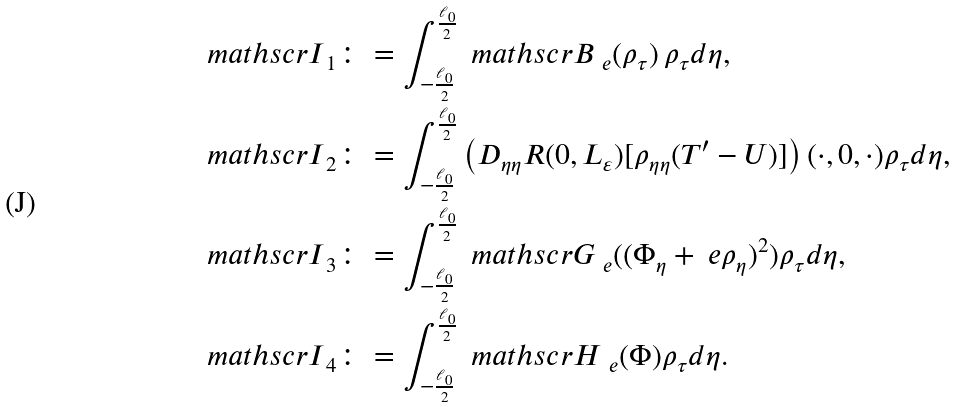Convert formula to latex. <formula><loc_0><loc_0><loc_500><loc_500>& { \ m a t h s c r I } _ { 1 } \colon = \int _ { - \frac { \ell _ { 0 } } { 2 } } ^ { \frac { \ell _ { 0 } } { 2 } } { \ m a t h s c r B } _ { \ e } ( \rho _ { \tau } ) \, \rho _ { \tau } d \eta , \\ & { \ m a t h s c r I } _ { 2 } \colon = \int _ { - \frac { \ell _ { 0 } } { 2 } } ^ { \frac { \ell _ { 0 } } { 2 } } \left ( D _ { \eta \eta } R ( 0 , L _ { \varepsilon } ) [ \rho _ { \eta \eta } ( { T } ^ { \prime } - { U } ) ] \right ) ( \cdot , 0 , \cdot ) \rho _ { \tau } d \eta , \\ & { \ m a t h s c r I } _ { 3 } \colon = \int _ { - \frac { \ell _ { 0 } } { 2 } } ^ { \frac { \ell _ { 0 } } { 2 } } { \ m a t h s c r G } _ { \ e } ( ( \Phi _ { \eta } + \ e \rho _ { \eta } ) ^ { 2 } ) \rho _ { \tau } d \eta , \\ & { \ m a t h s c r I } _ { 4 } \colon = \int _ { - \frac { \ell _ { 0 } } { 2 } } ^ { \frac { \ell _ { 0 } } { 2 } } { \ m a t h s c r H } _ { \ e } ( \Phi ) \rho _ { \tau } d \eta .</formula> 